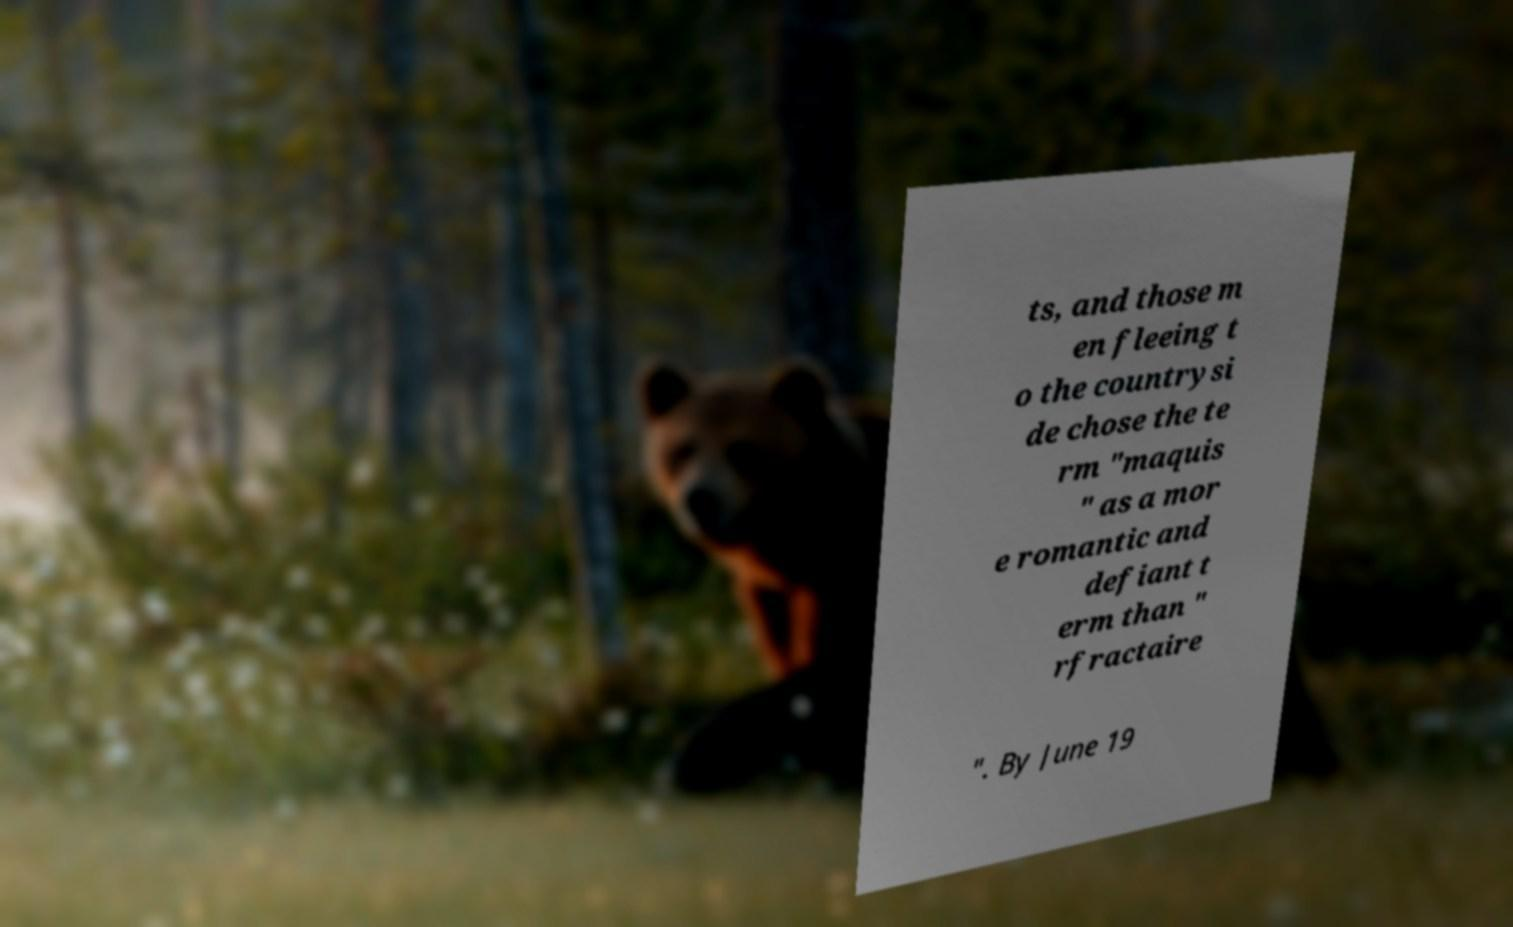For documentation purposes, I need the text within this image transcribed. Could you provide that? ts, and those m en fleeing t o the countrysi de chose the te rm "maquis " as a mor e romantic and defiant t erm than " rfractaire ". By June 19 